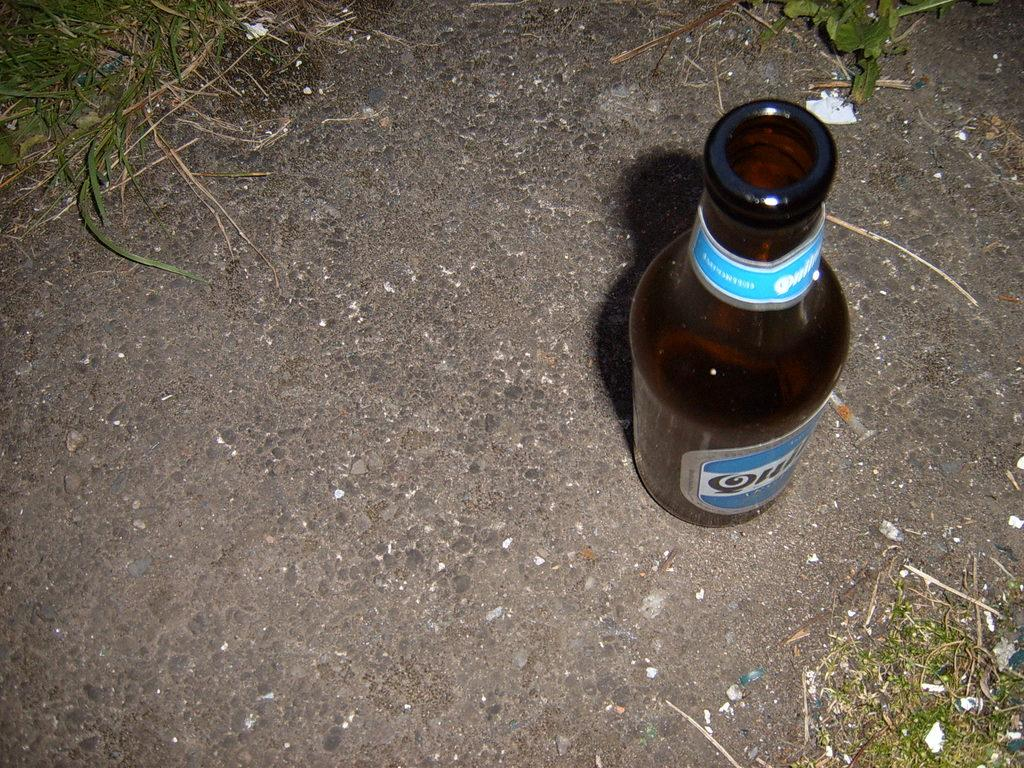What object can be seen in the image? There is a bottle in the image. What type of surface is visible beneath the object? The ground is visible in the image. What type of vegetation is present in the image? There is grass in the image. What type of minister is depicted in the image? There is no minister present in the image; it only features a bottle, the ground, and grass. 